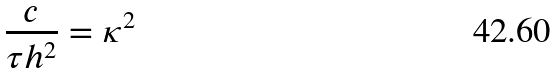<formula> <loc_0><loc_0><loc_500><loc_500>\frac { c } { \tau { h ^ { 2 } } } = { \kappa } ^ { 2 }</formula> 